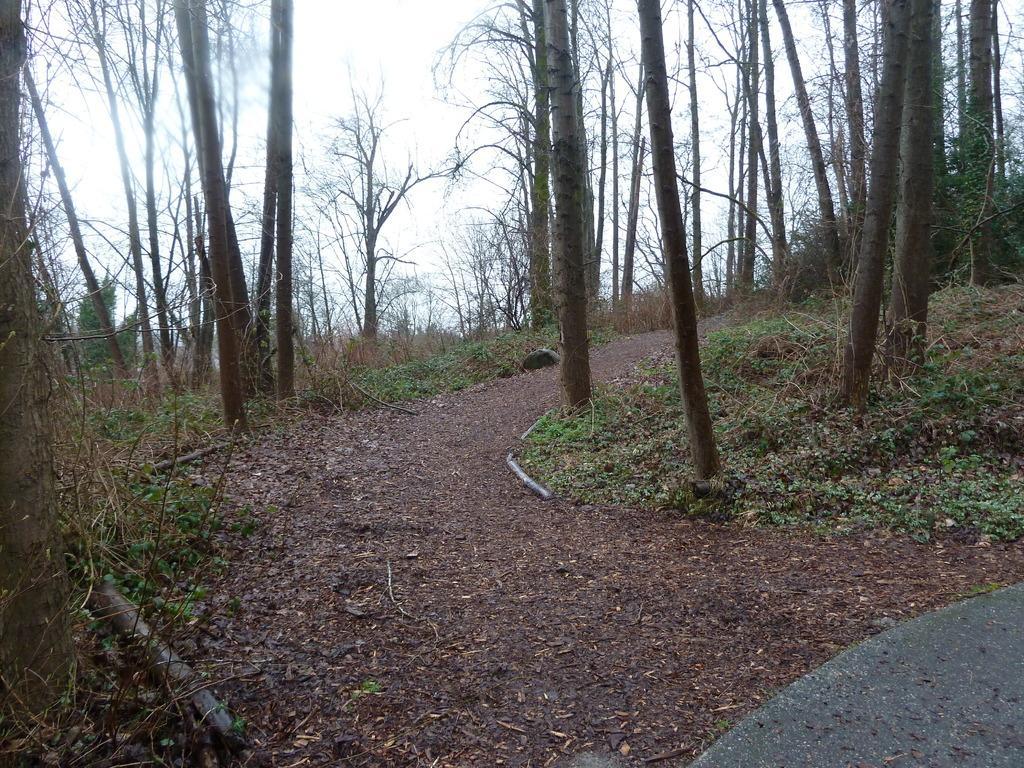In one or two sentences, can you explain what this image depicts? In the picture I can see the trunk of trees in the middle of the image. In the background, I can see the trees. I can see small plants on the side of the walkway. 